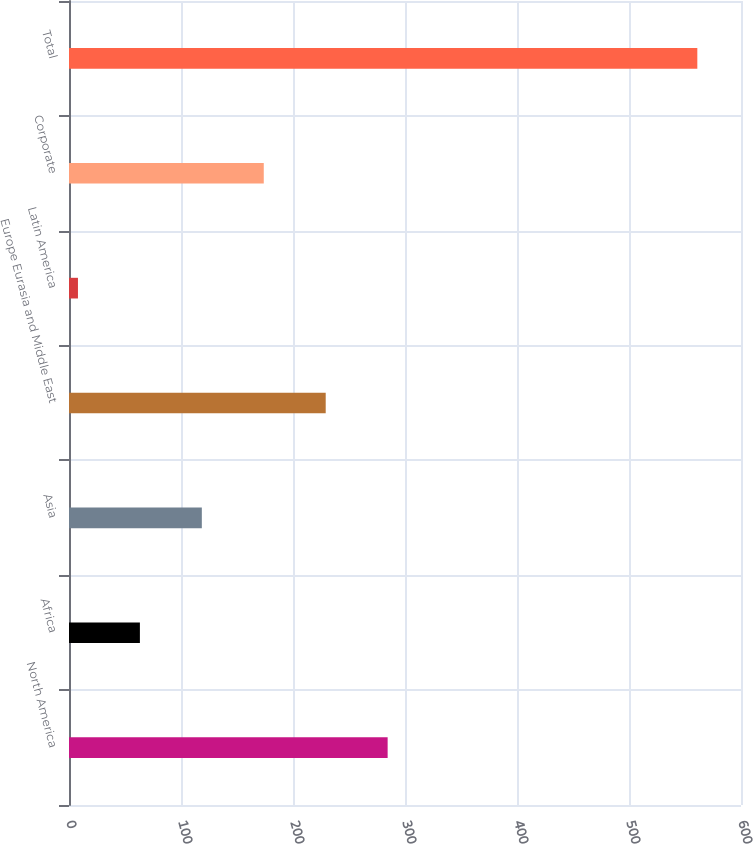Convert chart. <chart><loc_0><loc_0><loc_500><loc_500><bar_chart><fcel>North America<fcel>Africa<fcel>Asia<fcel>Europe Eurasia and Middle East<fcel>Latin America<fcel>Corporate<fcel>Total<nl><fcel>284.5<fcel>63.3<fcel>118.6<fcel>229.2<fcel>8<fcel>173.9<fcel>561<nl></chart> 